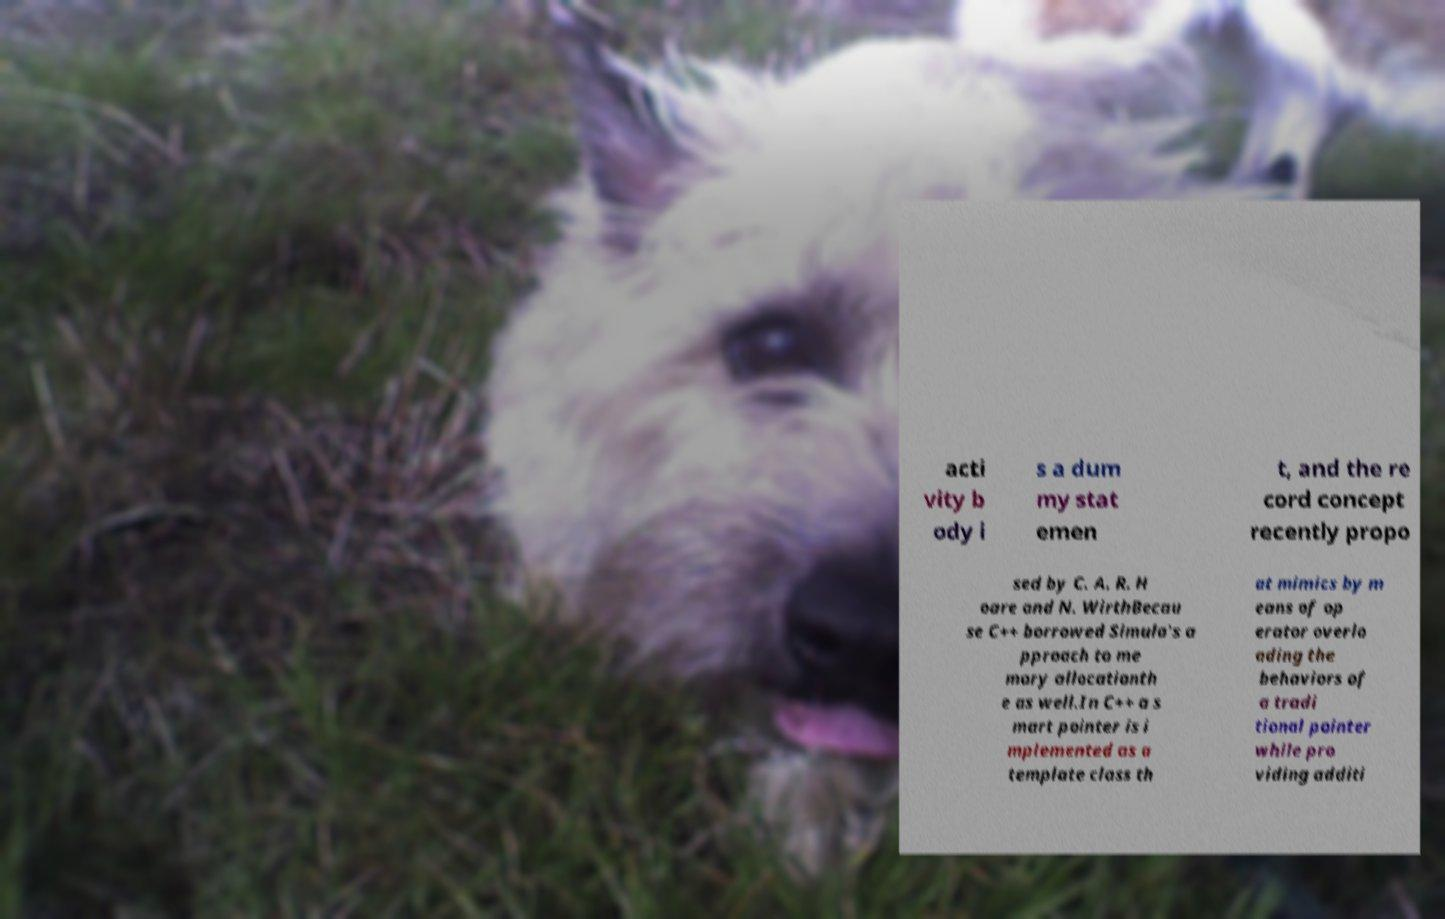For documentation purposes, I need the text within this image transcribed. Could you provide that? acti vity b ody i s a dum my stat emen t, and the re cord concept recently propo sed by C. A. R. H oare and N. WirthBecau se C++ borrowed Simula's a pproach to me mory allocationth e as well.In C++ a s mart pointer is i mplemented as a template class th at mimics by m eans of op erator overlo ading the behaviors of a tradi tional pointer while pro viding additi 